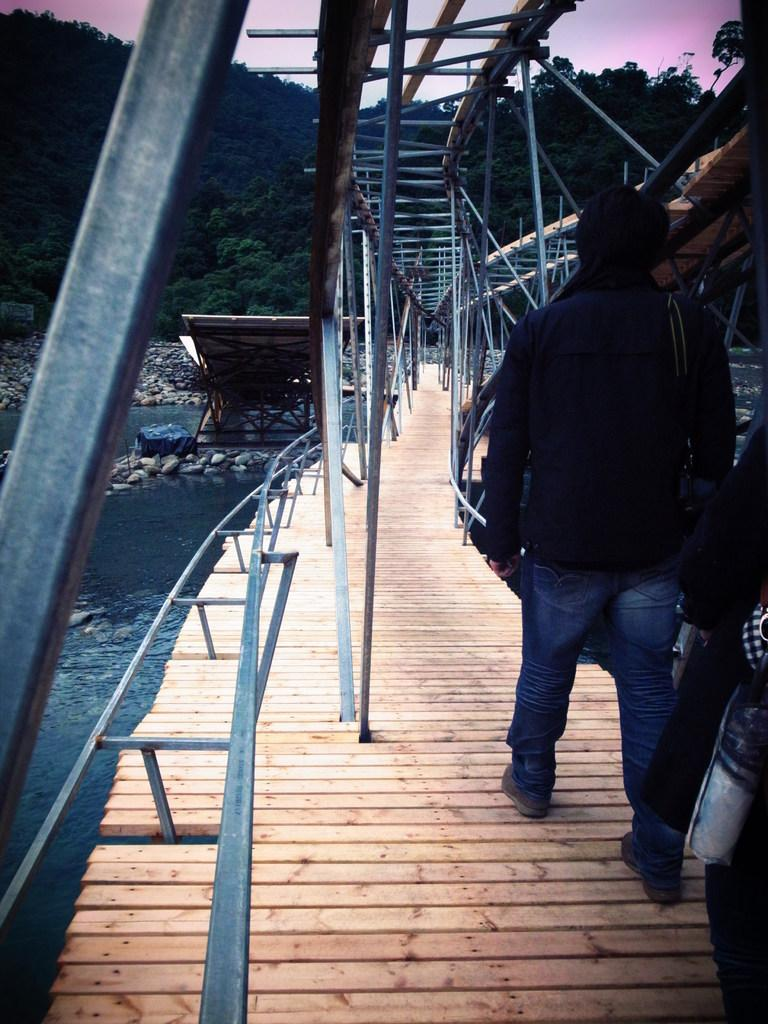How many people are in the image? There are two people in the image. What is one person doing in the image? One person is walking on a bridge. What type of structures can be seen in the image? There are poles in the image. What type of natural elements can be seen in the image? There are stones, trees, mountains, and water visible in the image. What else can be seen in the image? There are some unspecified objects in the image. What is visible in the background of the image? The sky is visible in the background of the image. What color is the ball that is being burst by the person walking on the bridge? There is no ball present in the image, nor is anyone bursting anything. 